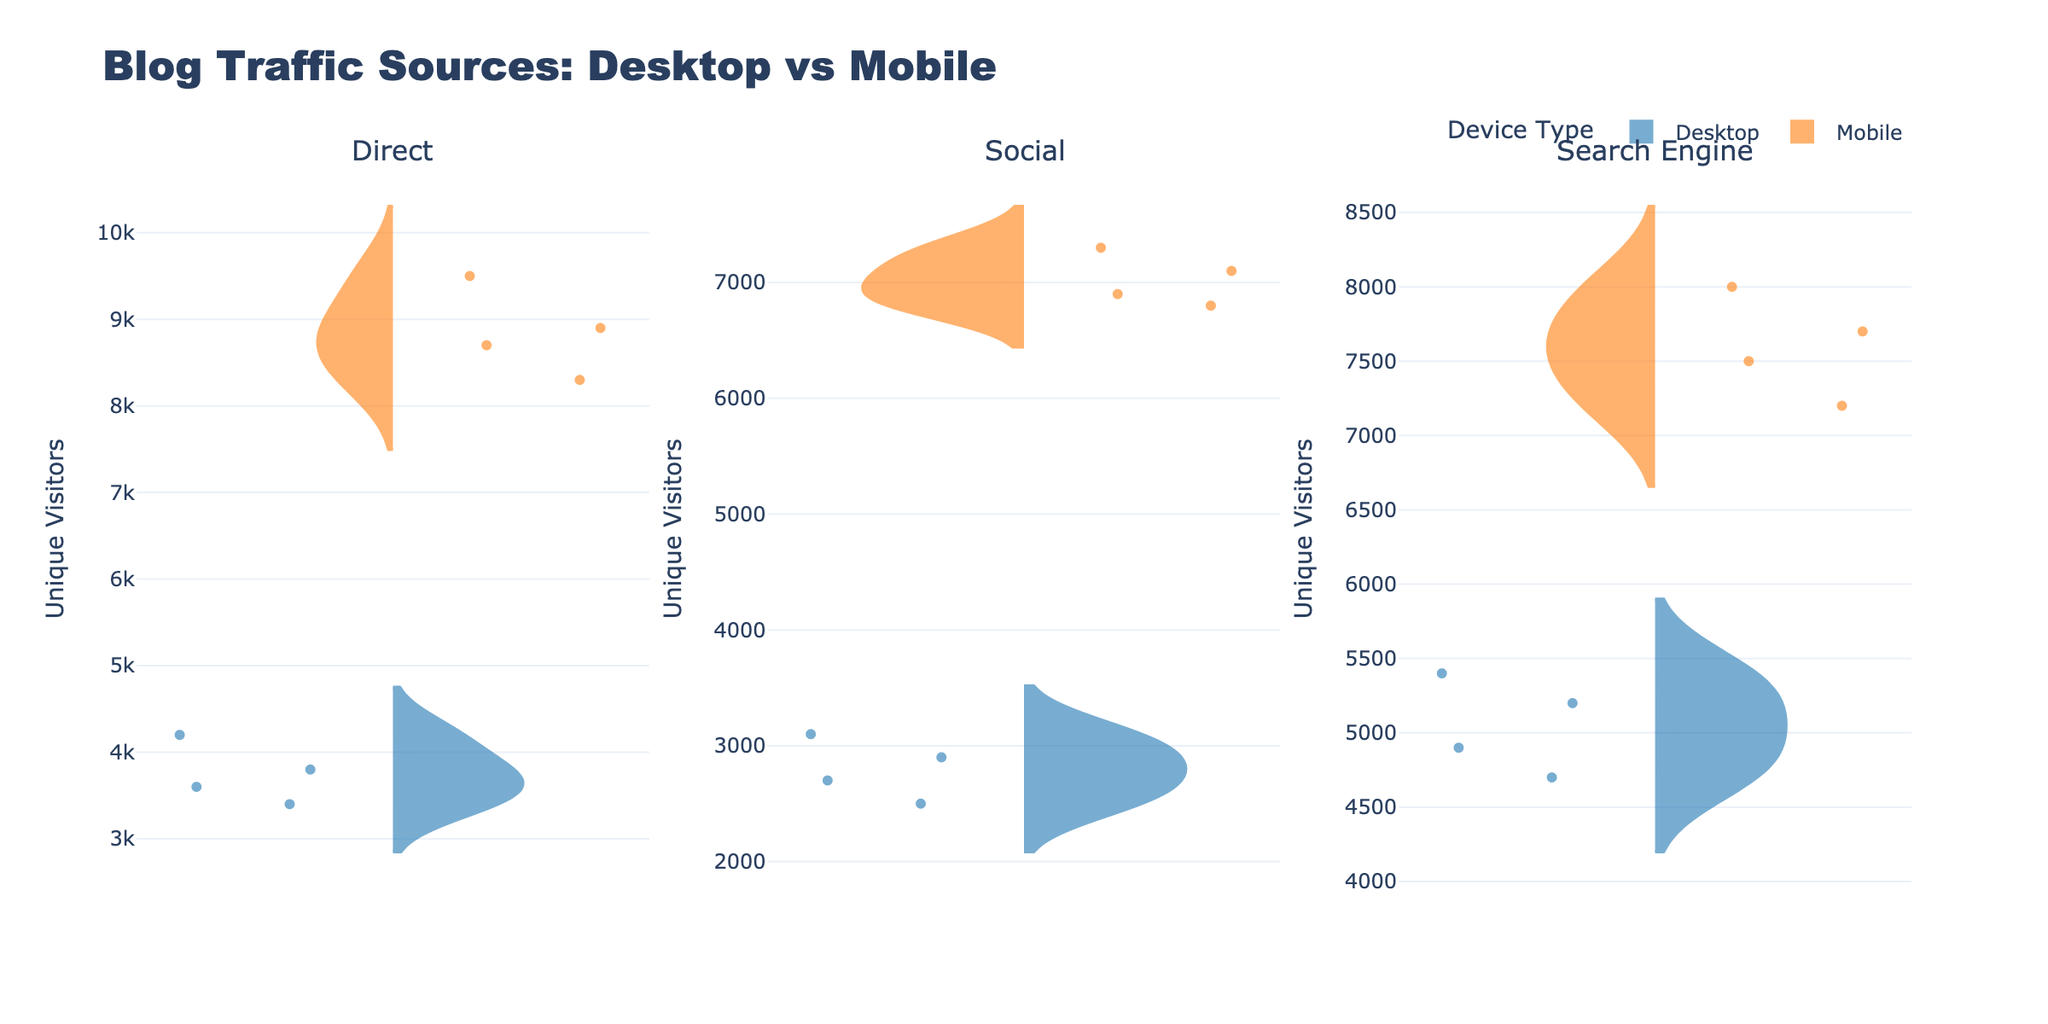What is the title of the plot? The title is located at the top of the plot and clearly states the main subject of the visualized data.
Answer: Blog Traffic Sources: Desktop vs Mobile How many subplot titles are there and what are they? There are three subplot titles shown at the top of each subplot. They are 'Direct', 'Social', and 'Search Engine'.
Answer: Three: Direct, Social, Search Engine Which device type has more variance in the 'Direct' traffic source, Desktop or Mobile? We can determine the variance by looking at the spread of the data points in the violin plot. The mobile violin plot has a wider spread compared to the desktop violin plot, indicating higher variance.
Answer: Mobile For the 'Search Engine' traffic source, what is the average number of unique visitors for Desktop devices? Look at the mean line in the violin plot for the 'Search Engine' traffic source under Desktop devices. The mean line usually represents the average value.
Answer: Around 5050 How do the median unique visitors for Mobile and Desktop devices in 'Social' traffic compare? The median is the middle line in the box within the violin plot. Compare the medians for Mobile and Desktop devices under the 'Social' traffic source. Mobile has a higher median than Desktop.
Answer: Mobile Which blog, on average, has the highest direct mobile traffic? By observing the violin plot for 'Direct' traffic on Mobile, identify the blog with the highest average position indicated by the mean line.
Answer: Mashable What is the interquartile range of unique visitors for Desktop devices in 'Direct' traffic source? Find the box within the Desktop violin plot for 'Direct' traffic. The interquartile range is the distance between the 25th percentile (bottom of the box) and the 75th percentile (top of the box).
Answer: Approximately 800 visitors Is there more overlap between Desktop and Mobile device traffic for 'Social' or 'Search Engine' sources? Check the extent to which the data distributions overlap in their respective violin plots. The overlap is more evident in 'Search Engine' sources compared to 'Social' sources.
Answer: Search Engine Which device type tends to have more unique visitors across all traffic sources? Compare the spread and central tendency of the violin plots for Desktop and Mobile across all traffic sources. Mobile tends to have more unique visitors.
Answer: Mobile What is the range of unique visitors for the 'Social' traffic source on Desktop devices? The range is the difference between the maximum and minimum values in the violin plot for Desktop devices under the 'Social' traffic source.
Answer: From 2500 to 3100 